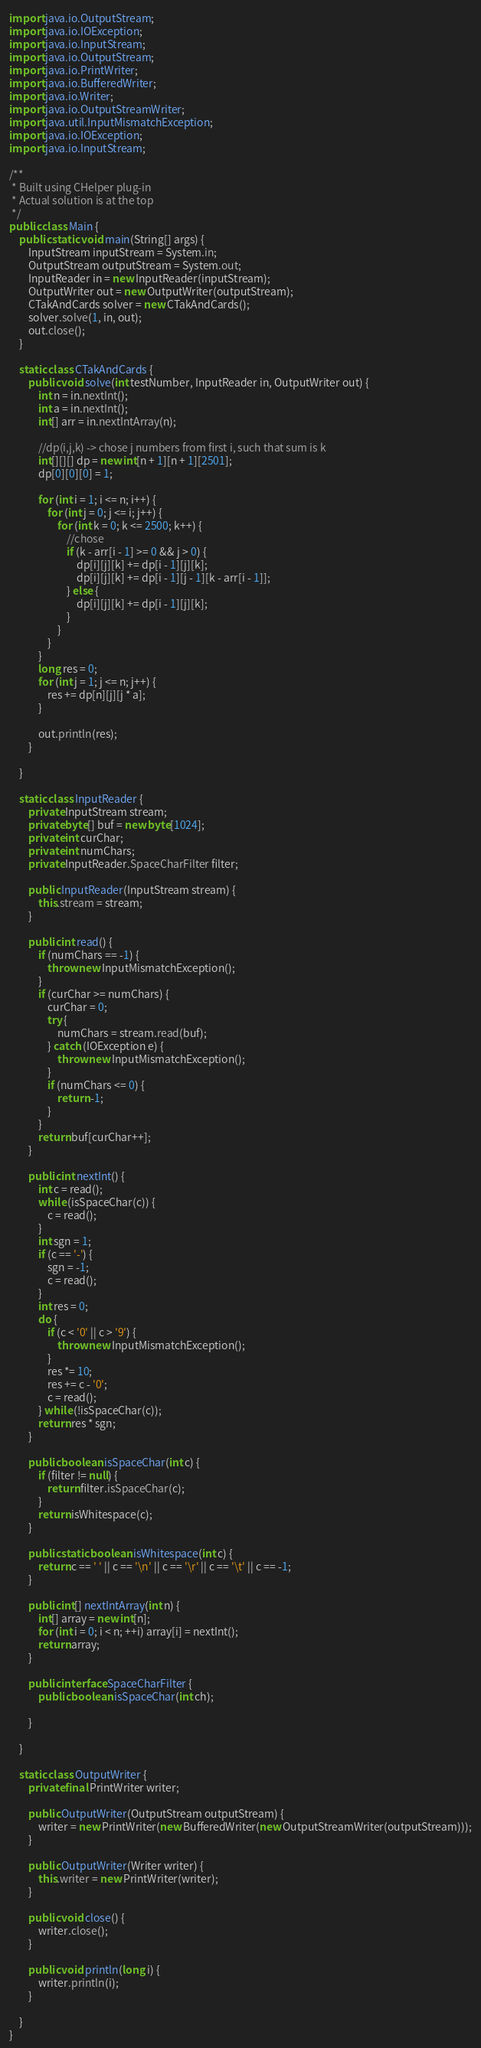<code> <loc_0><loc_0><loc_500><loc_500><_Java_>import java.io.OutputStream;
import java.io.IOException;
import java.io.InputStream;
import java.io.OutputStream;
import java.io.PrintWriter;
import java.io.BufferedWriter;
import java.io.Writer;
import java.io.OutputStreamWriter;
import java.util.InputMismatchException;
import java.io.IOException;
import java.io.InputStream;

/**
 * Built using CHelper plug-in
 * Actual solution is at the top
 */
public class Main {
    public static void main(String[] args) {
        InputStream inputStream = System.in;
        OutputStream outputStream = System.out;
        InputReader in = new InputReader(inputStream);
        OutputWriter out = new OutputWriter(outputStream);
        CTakAndCards solver = new CTakAndCards();
        solver.solve(1, in, out);
        out.close();
    }

    static class CTakAndCards {
        public void solve(int testNumber, InputReader in, OutputWriter out) {
            int n = in.nextInt();
            int a = in.nextInt();
            int[] arr = in.nextIntArray(n);

            //dp(i,j,k) -> chose j numbers from first i, such that sum is k
            int[][][] dp = new int[n + 1][n + 1][2501];
            dp[0][0][0] = 1;

            for (int i = 1; i <= n; i++) {
                for (int j = 0; j <= i; j++) {
                    for (int k = 0; k <= 2500; k++) {
                        //chose
                        if (k - arr[i - 1] >= 0 && j > 0) {
                            dp[i][j][k] += dp[i - 1][j][k];
                            dp[i][j][k] += dp[i - 1][j - 1][k - arr[i - 1]];
                        } else {
                            dp[i][j][k] += dp[i - 1][j][k];
                        }
                    }
                }
            }
            long res = 0;
            for (int j = 1; j <= n; j++) {
                res += dp[n][j][j * a];
            }

            out.println(res);
        }

    }

    static class InputReader {
        private InputStream stream;
        private byte[] buf = new byte[1024];
        private int curChar;
        private int numChars;
        private InputReader.SpaceCharFilter filter;

        public InputReader(InputStream stream) {
            this.stream = stream;
        }

        public int read() {
            if (numChars == -1) {
                throw new InputMismatchException();
            }
            if (curChar >= numChars) {
                curChar = 0;
                try {
                    numChars = stream.read(buf);
                } catch (IOException e) {
                    throw new InputMismatchException();
                }
                if (numChars <= 0) {
                    return -1;
                }
            }
            return buf[curChar++];
        }

        public int nextInt() {
            int c = read();
            while (isSpaceChar(c)) {
                c = read();
            }
            int sgn = 1;
            if (c == '-') {
                sgn = -1;
                c = read();
            }
            int res = 0;
            do {
                if (c < '0' || c > '9') {
                    throw new InputMismatchException();
                }
                res *= 10;
                res += c - '0';
                c = read();
            } while (!isSpaceChar(c));
            return res * sgn;
        }

        public boolean isSpaceChar(int c) {
            if (filter != null) {
                return filter.isSpaceChar(c);
            }
            return isWhitespace(c);
        }

        public static boolean isWhitespace(int c) {
            return c == ' ' || c == '\n' || c == '\r' || c == '\t' || c == -1;
        }

        public int[] nextIntArray(int n) {
            int[] array = new int[n];
            for (int i = 0; i < n; ++i) array[i] = nextInt();
            return array;
        }

        public interface SpaceCharFilter {
            public boolean isSpaceChar(int ch);

        }

    }

    static class OutputWriter {
        private final PrintWriter writer;

        public OutputWriter(OutputStream outputStream) {
            writer = new PrintWriter(new BufferedWriter(new OutputStreamWriter(outputStream)));
        }

        public OutputWriter(Writer writer) {
            this.writer = new PrintWriter(writer);
        }

        public void close() {
            writer.close();
        }

        public void println(long i) {
            writer.println(i);
        }

    }
}

</code> 